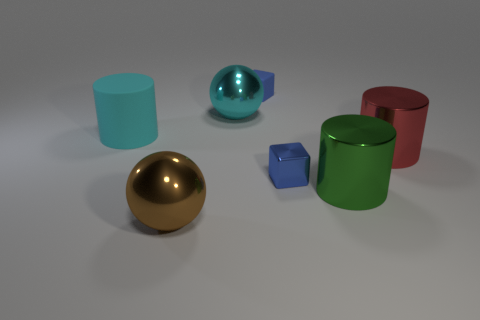Add 1 red metal cylinders. How many objects exist? 8 Subtract all cylinders. How many objects are left? 4 Add 6 green objects. How many green objects are left? 7 Add 1 spheres. How many spheres exist? 3 Subtract 0 yellow cylinders. How many objects are left? 7 Subtract all gray shiny objects. Subtract all big brown shiny spheres. How many objects are left? 6 